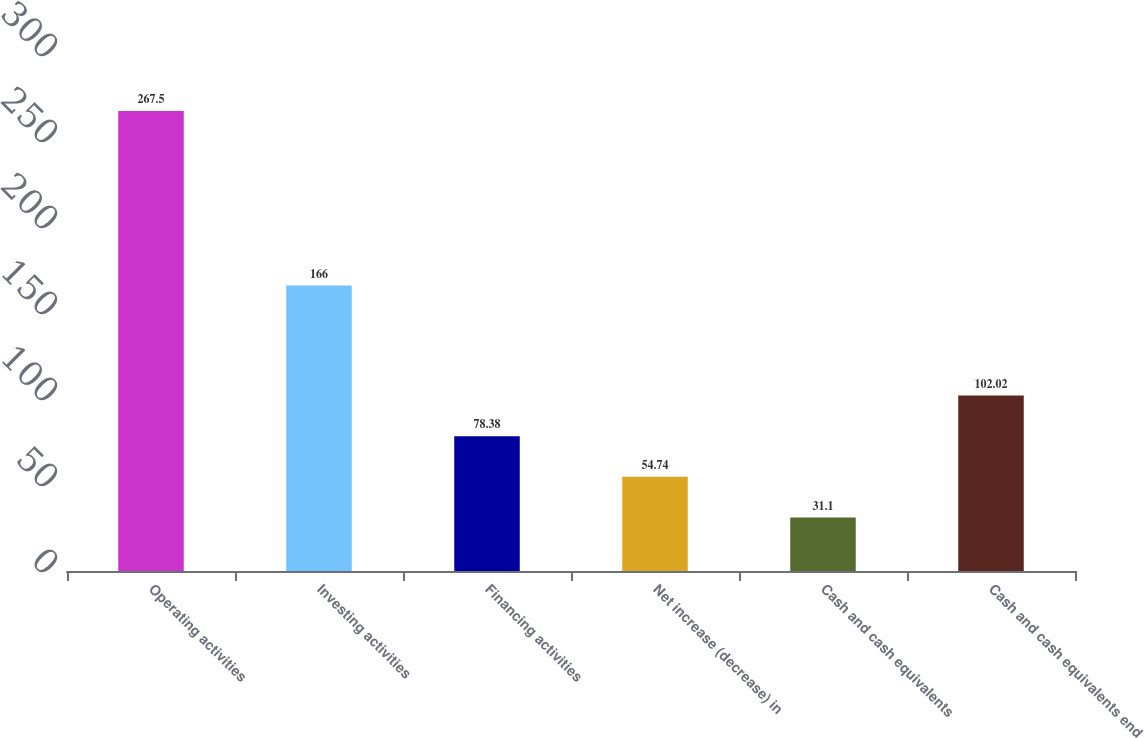Convert chart to OTSL. <chart><loc_0><loc_0><loc_500><loc_500><bar_chart><fcel>Operating activities<fcel>Investing activities<fcel>Financing activities<fcel>Net increase (decrease) in<fcel>Cash and cash equivalents<fcel>Cash and cash equivalents end<nl><fcel>267.5<fcel>166<fcel>78.38<fcel>54.74<fcel>31.1<fcel>102.02<nl></chart> 